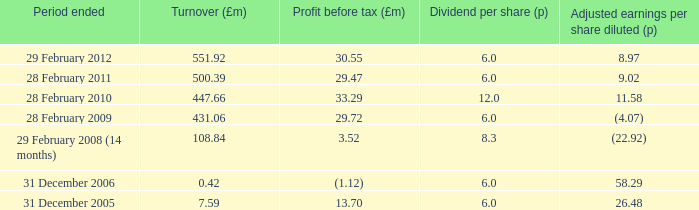47? 500.39. 